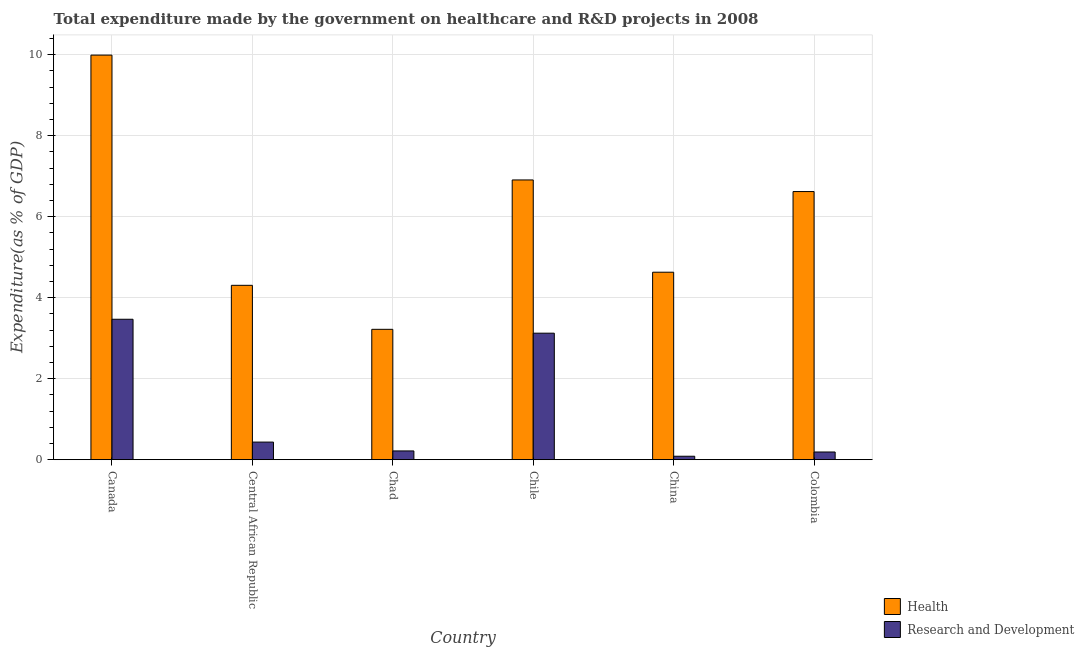How many groups of bars are there?
Keep it short and to the point. 6. Are the number of bars on each tick of the X-axis equal?
Keep it short and to the point. Yes. How many bars are there on the 3rd tick from the left?
Offer a very short reply. 2. What is the label of the 3rd group of bars from the left?
Your response must be concise. Chad. In how many cases, is the number of bars for a given country not equal to the number of legend labels?
Provide a succinct answer. 0. What is the expenditure in healthcare in Chad?
Provide a short and direct response. 3.22. Across all countries, what is the maximum expenditure in healthcare?
Offer a terse response. 9.99. Across all countries, what is the minimum expenditure in healthcare?
Provide a succinct answer. 3.22. In which country was the expenditure in r&d minimum?
Your answer should be very brief. China. What is the total expenditure in healthcare in the graph?
Your answer should be very brief. 35.67. What is the difference between the expenditure in healthcare in Chad and that in Chile?
Keep it short and to the point. -3.69. What is the difference between the expenditure in healthcare in Canada and the expenditure in r&d in Colombia?
Provide a short and direct response. 9.8. What is the average expenditure in r&d per country?
Ensure brevity in your answer.  1.25. What is the difference between the expenditure in r&d and expenditure in healthcare in Chile?
Keep it short and to the point. -3.78. What is the ratio of the expenditure in r&d in Canada to that in Chad?
Your answer should be compact. 16.01. Is the expenditure in r&d in Chad less than that in Chile?
Keep it short and to the point. Yes. Is the difference between the expenditure in healthcare in Canada and Chile greater than the difference between the expenditure in r&d in Canada and Chile?
Offer a terse response. Yes. What is the difference between the highest and the second highest expenditure in healthcare?
Your answer should be compact. 3.08. What is the difference between the highest and the lowest expenditure in r&d?
Offer a very short reply. 3.38. What does the 2nd bar from the left in Chile represents?
Your response must be concise. Research and Development. What does the 1st bar from the right in China represents?
Provide a succinct answer. Research and Development. How many bars are there?
Give a very brief answer. 12. Are all the bars in the graph horizontal?
Ensure brevity in your answer.  No. How many countries are there in the graph?
Your answer should be compact. 6. What is the difference between two consecutive major ticks on the Y-axis?
Your answer should be compact. 2. Are the values on the major ticks of Y-axis written in scientific E-notation?
Ensure brevity in your answer.  No. How many legend labels are there?
Provide a short and direct response. 2. What is the title of the graph?
Your response must be concise. Total expenditure made by the government on healthcare and R&D projects in 2008. What is the label or title of the Y-axis?
Keep it short and to the point. Expenditure(as % of GDP). What is the Expenditure(as % of GDP) in Health in Canada?
Your answer should be very brief. 9.99. What is the Expenditure(as % of GDP) of Research and Development in Canada?
Your response must be concise. 3.47. What is the Expenditure(as % of GDP) in Health in Central African Republic?
Give a very brief answer. 4.3. What is the Expenditure(as % of GDP) of Research and Development in Central African Republic?
Give a very brief answer. 0.43. What is the Expenditure(as % of GDP) in Health in Chad?
Your answer should be compact. 3.22. What is the Expenditure(as % of GDP) of Research and Development in Chad?
Your response must be concise. 0.22. What is the Expenditure(as % of GDP) of Health in Chile?
Provide a short and direct response. 6.91. What is the Expenditure(as % of GDP) of Research and Development in Chile?
Make the answer very short. 3.12. What is the Expenditure(as % of GDP) of Health in China?
Offer a terse response. 4.63. What is the Expenditure(as % of GDP) in Research and Development in China?
Provide a succinct answer. 0.09. What is the Expenditure(as % of GDP) in Health in Colombia?
Keep it short and to the point. 6.62. What is the Expenditure(as % of GDP) of Research and Development in Colombia?
Offer a terse response. 0.19. Across all countries, what is the maximum Expenditure(as % of GDP) in Health?
Ensure brevity in your answer.  9.99. Across all countries, what is the maximum Expenditure(as % of GDP) in Research and Development?
Make the answer very short. 3.47. Across all countries, what is the minimum Expenditure(as % of GDP) in Health?
Provide a succinct answer. 3.22. Across all countries, what is the minimum Expenditure(as % of GDP) of Research and Development?
Provide a succinct answer. 0.09. What is the total Expenditure(as % of GDP) of Health in the graph?
Keep it short and to the point. 35.67. What is the total Expenditure(as % of GDP) of Research and Development in the graph?
Give a very brief answer. 7.52. What is the difference between the Expenditure(as % of GDP) in Health in Canada and that in Central African Republic?
Your answer should be compact. 5.68. What is the difference between the Expenditure(as % of GDP) of Research and Development in Canada and that in Central African Republic?
Ensure brevity in your answer.  3.03. What is the difference between the Expenditure(as % of GDP) of Health in Canada and that in Chad?
Keep it short and to the point. 6.77. What is the difference between the Expenditure(as % of GDP) of Research and Development in Canada and that in Chad?
Your response must be concise. 3.25. What is the difference between the Expenditure(as % of GDP) of Health in Canada and that in Chile?
Provide a short and direct response. 3.08. What is the difference between the Expenditure(as % of GDP) of Research and Development in Canada and that in Chile?
Provide a short and direct response. 0.34. What is the difference between the Expenditure(as % of GDP) of Health in Canada and that in China?
Your response must be concise. 5.36. What is the difference between the Expenditure(as % of GDP) in Research and Development in Canada and that in China?
Offer a terse response. 3.38. What is the difference between the Expenditure(as % of GDP) of Health in Canada and that in Colombia?
Your response must be concise. 3.37. What is the difference between the Expenditure(as % of GDP) of Research and Development in Canada and that in Colombia?
Ensure brevity in your answer.  3.28. What is the difference between the Expenditure(as % of GDP) of Health in Central African Republic and that in Chad?
Offer a terse response. 1.09. What is the difference between the Expenditure(as % of GDP) in Research and Development in Central African Republic and that in Chad?
Provide a succinct answer. 0.22. What is the difference between the Expenditure(as % of GDP) in Health in Central African Republic and that in Chile?
Provide a short and direct response. -2.6. What is the difference between the Expenditure(as % of GDP) of Research and Development in Central African Republic and that in Chile?
Provide a short and direct response. -2.69. What is the difference between the Expenditure(as % of GDP) in Health in Central African Republic and that in China?
Your answer should be compact. -0.32. What is the difference between the Expenditure(as % of GDP) in Research and Development in Central African Republic and that in China?
Offer a terse response. 0.35. What is the difference between the Expenditure(as % of GDP) in Health in Central African Republic and that in Colombia?
Your answer should be compact. -2.31. What is the difference between the Expenditure(as % of GDP) in Research and Development in Central African Republic and that in Colombia?
Give a very brief answer. 0.24. What is the difference between the Expenditure(as % of GDP) of Health in Chad and that in Chile?
Offer a very short reply. -3.69. What is the difference between the Expenditure(as % of GDP) in Research and Development in Chad and that in Chile?
Your response must be concise. -2.91. What is the difference between the Expenditure(as % of GDP) in Health in Chad and that in China?
Offer a very short reply. -1.41. What is the difference between the Expenditure(as % of GDP) of Research and Development in Chad and that in China?
Offer a very short reply. 0.13. What is the difference between the Expenditure(as % of GDP) in Health in Chad and that in Colombia?
Make the answer very short. -3.4. What is the difference between the Expenditure(as % of GDP) in Research and Development in Chad and that in Colombia?
Offer a terse response. 0.03. What is the difference between the Expenditure(as % of GDP) in Health in Chile and that in China?
Offer a very short reply. 2.28. What is the difference between the Expenditure(as % of GDP) of Research and Development in Chile and that in China?
Your answer should be very brief. 3.04. What is the difference between the Expenditure(as % of GDP) of Health in Chile and that in Colombia?
Make the answer very short. 0.29. What is the difference between the Expenditure(as % of GDP) in Research and Development in Chile and that in Colombia?
Your answer should be compact. 2.93. What is the difference between the Expenditure(as % of GDP) in Health in China and that in Colombia?
Provide a succinct answer. -1.99. What is the difference between the Expenditure(as % of GDP) in Research and Development in China and that in Colombia?
Give a very brief answer. -0.1. What is the difference between the Expenditure(as % of GDP) of Health in Canada and the Expenditure(as % of GDP) of Research and Development in Central African Republic?
Offer a very short reply. 9.55. What is the difference between the Expenditure(as % of GDP) of Health in Canada and the Expenditure(as % of GDP) of Research and Development in Chad?
Provide a succinct answer. 9.77. What is the difference between the Expenditure(as % of GDP) of Health in Canada and the Expenditure(as % of GDP) of Research and Development in Chile?
Your answer should be very brief. 6.87. What is the difference between the Expenditure(as % of GDP) of Health in Canada and the Expenditure(as % of GDP) of Research and Development in China?
Give a very brief answer. 9.9. What is the difference between the Expenditure(as % of GDP) in Health in Canada and the Expenditure(as % of GDP) in Research and Development in Colombia?
Your response must be concise. 9.8. What is the difference between the Expenditure(as % of GDP) in Health in Central African Republic and the Expenditure(as % of GDP) in Research and Development in Chad?
Give a very brief answer. 4.09. What is the difference between the Expenditure(as % of GDP) of Health in Central African Republic and the Expenditure(as % of GDP) of Research and Development in Chile?
Offer a very short reply. 1.18. What is the difference between the Expenditure(as % of GDP) of Health in Central African Republic and the Expenditure(as % of GDP) of Research and Development in China?
Keep it short and to the point. 4.22. What is the difference between the Expenditure(as % of GDP) in Health in Central African Republic and the Expenditure(as % of GDP) in Research and Development in Colombia?
Give a very brief answer. 4.11. What is the difference between the Expenditure(as % of GDP) of Health in Chad and the Expenditure(as % of GDP) of Research and Development in Chile?
Provide a succinct answer. 0.1. What is the difference between the Expenditure(as % of GDP) of Health in Chad and the Expenditure(as % of GDP) of Research and Development in China?
Offer a very short reply. 3.13. What is the difference between the Expenditure(as % of GDP) of Health in Chad and the Expenditure(as % of GDP) of Research and Development in Colombia?
Give a very brief answer. 3.03. What is the difference between the Expenditure(as % of GDP) in Health in Chile and the Expenditure(as % of GDP) in Research and Development in China?
Give a very brief answer. 6.82. What is the difference between the Expenditure(as % of GDP) in Health in Chile and the Expenditure(as % of GDP) in Research and Development in Colombia?
Make the answer very short. 6.72. What is the difference between the Expenditure(as % of GDP) of Health in China and the Expenditure(as % of GDP) of Research and Development in Colombia?
Make the answer very short. 4.44. What is the average Expenditure(as % of GDP) in Health per country?
Your answer should be very brief. 5.94. What is the average Expenditure(as % of GDP) in Research and Development per country?
Ensure brevity in your answer.  1.25. What is the difference between the Expenditure(as % of GDP) in Health and Expenditure(as % of GDP) in Research and Development in Canada?
Make the answer very short. 6.52. What is the difference between the Expenditure(as % of GDP) in Health and Expenditure(as % of GDP) in Research and Development in Central African Republic?
Ensure brevity in your answer.  3.87. What is the difference between the Expenditure(as % of GDP) in Health and Expenditure(as % of GDP) in Research and Development in Chad?
Make the answer very short. 3. What is the difference between the Expenditure(as % of GDP) in Health and Expenditure(as % of GDP) in Research and Development in Chile?
Your answer should be compact. 3.78. What is the difference between the Expenditure(as % of GDP) in Health and Expenditure(as % of GDP) in Research and Development in China?
Offer a terse response. 4.54. What is the difference between the Expenditure(as % of GDP) in Health and Expenditure(as % of GDP) in Research and Development in Colombia?
Your answer should be compact. 6.43. What is the ratio of the Expenditure(as % of GDP) of Health in Canada to that in Central African Republic?
Your answer should be very brief. 2.32. What is the ratio of the Expenditure(as % of GDP) of Research and Development in Canada to that in Central African Republic?
Provide a succinct answer. 7.98. What is the ratio of the Expenditure(as % of GDP) in Health in Canada to that in Chad?
Your response must be concise. 3.1. What is the ratio of the Expenditure(as % of GDP) in Research and Development in Canada to that in Chad?
Make the answer very short. 16.01. What is the ratio of the Expenditure(as % of GDP) of Health in Canada to that in Chile?
Make the answer very short. 1.45. What is the ratio of the Expenditure(as % of GDP) of Research and Development in Canada to that in Chile?
Keep it short and to the point. 1.11. What is the ratio of the Expenditure(as % of GDP) of Health in Canada to that in China?
Keep it short and to the point. 2.16. What is the ratio of the Expenditure(as % of GDP) of Research and Development in Canada to that in China?
Your answer should be very brief. 40.55. What is the ratio of the Expenditure(as % of GDP) in Health in Canada to that in Colombia?
Your response must be concise. 1.51. What is the ratio of the Expenditure(as % of GDP) in Research and Development in Canada to that in Colombia?
Offer a very short reply. 18.23. What is the ratio of the Expenditure(as % of GDP) of Health in Central African Republic to that in Chad?
Offer a very short reply. 1.34. What is the ratio of the Expenditure(as % of GDP) of Research and Development in Central African Republic to that in Chad?
Ensure brevity in your answer.  2.01. What is the ratio of the Expenditure(as % of GDP) in Health in Central African Republic to that in Chile?
Your answer should be very brief. 0.62. What is the ratio of the Expenditure(as % of GDP) in Research and Development in Central African Republic to that in Chile?
Provide a short and direct response. 0.14. What is the ratio of the Expenditure(as % of GDP) in Health in Central African Republic to that in China?
Keep it short and to the point. 0.93. What is the ratio of the Expenditure(as % of GDP) of Research and Development in Central African Republic to that in China?
Your answer should be very brief. 5.08. What is the ratio of the Expenditure(as % of GDP) of Health in Central African Republic to that in Colombia?
Provide a succinct answer. 0.65. What is the ratio of the Expenditure(as % of GDP) of Research and Development in Central African Republic to that in Colombia?
Your answer should be compact. 2.29. What is the ratio of the Expenditure(as % of GDP) in Health in Chad to that in Chile?
Your answer should be very brief. 0.47. What is the ratio of the Expenditure(as % of GDP) in Research and Development in Chad to that in Chile?
Your answer should be compact. 0.07. What is the ratio of the Expenditure(as % of GDP) of Health in Chad to that in China?
Ensure brevity in your answer.  0.7. What is the ratio of the Expenditure(as % of GDP) in Research and Development in Chad to that in China?
Your response must be concise. 2.53. What is the ratio of the Expenditure(as % of GDP) of Health in Chad to that in Colombia?
Keep it short and to the point. 0.49. What is the ratio of the Expenditure(as % of GDP) in Research and Development in Chad to that in Colombia?
Your response must be concise. 1.14. What is the ratio of the Expenditure(as % of GDP) of Health in Chile to that in China?
Provide a short and direct response. 1.49. What is the ratio of the Expenditure(as % of GDP) of Research and Development in Chile to that in China?
Offer a very short reply. 36.53. What is the ratio of the Expenditure(as % of GDP) in Health in Chile to that in Colombia?
Your answer should be compact. 1.04. What is the ratio of the Expenditure(as % of GDP) of Research and Development in Chile to that in Colombia?
Give a very brief answer. 16.42. What is the ratio of the Expenditure(as % of GDP) of Health in China to that in Colombia?
Your answer should be compact. 0.7. What is the ratio of the Expenditure(as % of GDP) of Research and Development in China to that in Colombia?
Your answer should be very brief. 0.45. What is the difference between the highest and the second highest Expenditure(as % of GDP) of Health?
Offer a terse response. 3.08. What is the difference between the highest and the second highest Expenditure(as % of GDP) in Research and Development?
Your answer should be compact. 0.34. What is the difference between the highest and the lowest Expenditure(as % of GDP) in Health?
Offer a terse response. 6.77. What is the difference between the highest and the lowest Expenditure(as % of GDP) in Research and Development?
Make the answer very short. 3.38. 